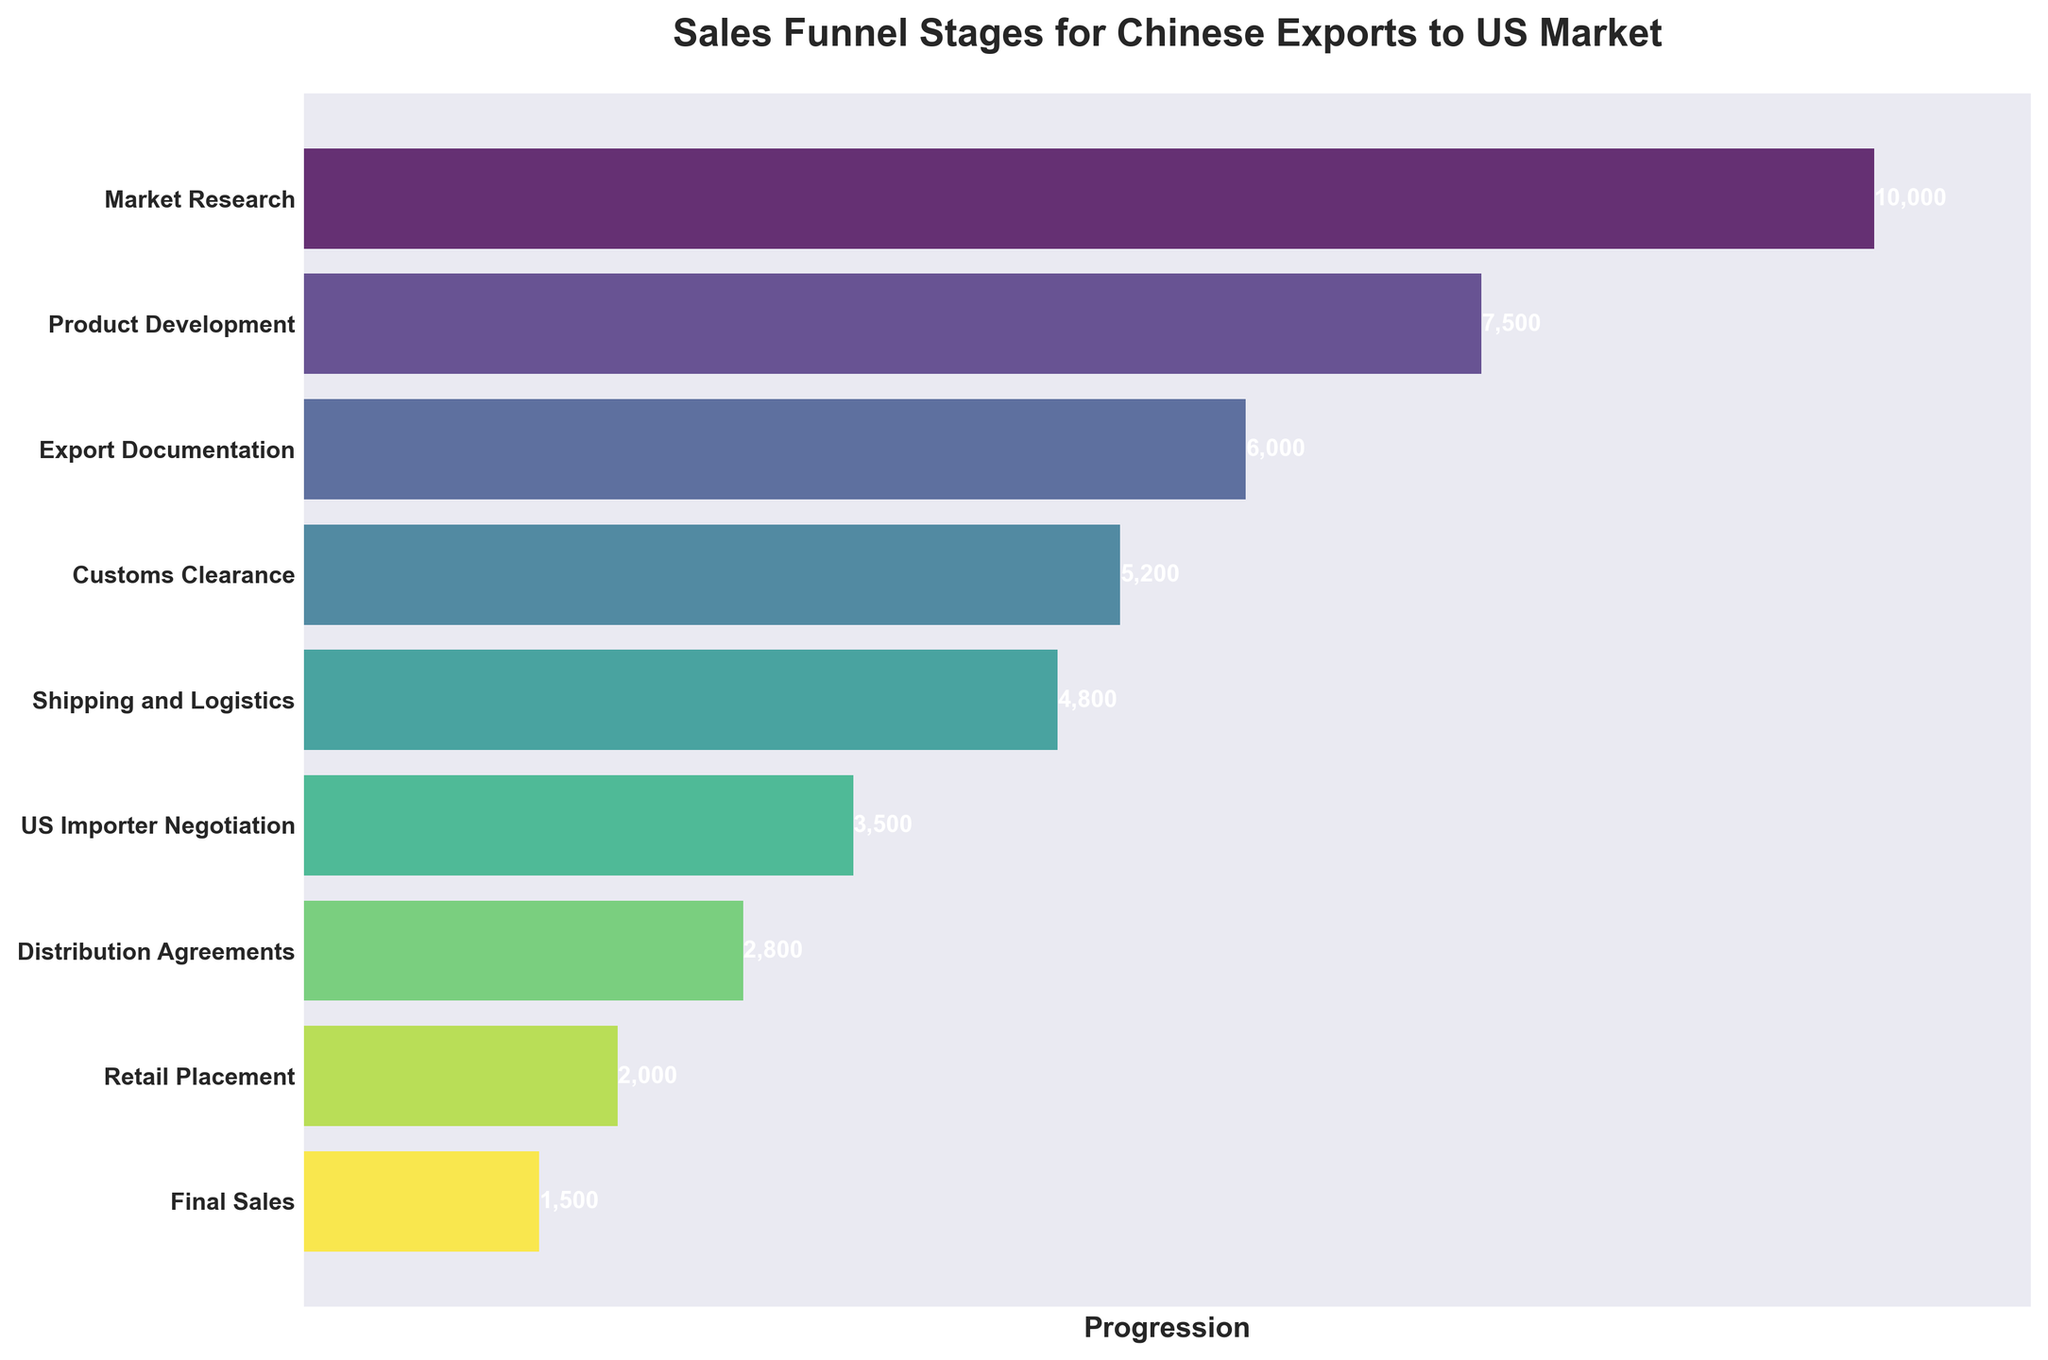What is the title of the funnel chart? The title is written at the top of the chart, making it clearly visible.
Answer: Sales Funnel Stages for Chinese Exports to US Market What is the value for 'Product Development'? The value is displayed as a white text on the bar representing 'Product Development'.
Answer: 7,500 How many stages are there in total? The total number of stages can be counted from the y-axis labels.
Answer: 9 What color scheme is used for the bars in the chart? The bars use a gradient color scheme that transitions from green to purple.
Answer: Gradient from green to purple What is the difference between 'Market Research' and 'Final Sales' in terms of count? Subtract the count of 'Final Sales' from the count of 'Market Research' using the displayed values: 10,000 - 1,500.
Answer: 8,500 Which stage has the smallest count? Identify the smallest value from the bars, which represents 'Final Sales'.
Answer: Final Sales How many stages have a count greater than 5,000? The counts greater than 5,000 are associated with the stages of 'Market Research', 'Product Development', and 'Export Documentation', totaling to three stages.
Answer: 3 What is the combined count for 'Shipping and Logistics' and 'Distribution Agreements'? Add the counts for these stages: 4,800 + 2,800.
Answer: 7,600 What stage comes immediately after 'US Importer Negotiation'? Read the label for the stage that follows 'US Importer Negotiation' on the y-axis.
Answer: Distribution Agreements Which stage shows the largest drop in count compared to its preceding stage? Calculate the difference between each stage and find the largest drop: 
- Market Research to Product Development: 10,000 - 7,500 = 2,500
- Product Development to Export Documentation: 7,500 - 6,000 = 1,500
- Export Documentation to Customs Clearance: 6,000 - 5,200 = 800
- Customs Clearance to Shipping and Logistics: 5,200 - 4,800 = 400
- Shipping and Logistics to US Importer Negotiation: 4,800 - 3,500 = 1,300
- US Importer Negotiation to Distribution Agreements: 3,500 - 2,800 = 700
- Distribution Agreements to Retail Placement: 2,800 - 2,000 = 800
- Retail Placement to Final Sales: 2,000 - 1,500 = 500
Among these, the largest drop is from Market Research to Product Development (2,500).
Answer: Market Research to Product Development 